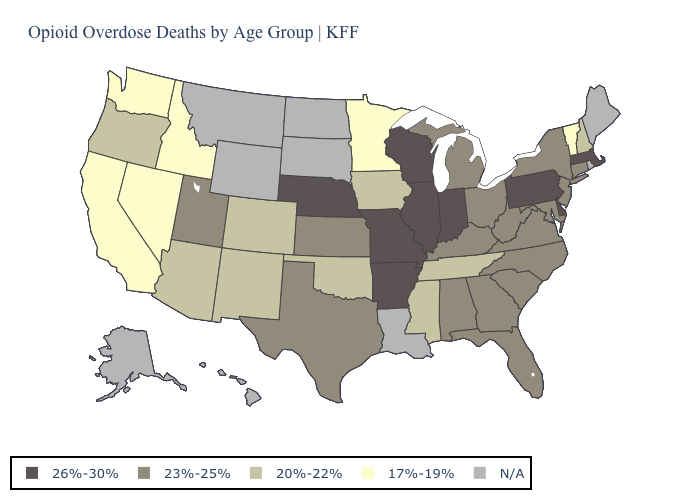What is the lowest value in the USA?
Give a very brief answer. 17%-19%. Among the states that border North Carolina , which have the highest value?
Keep it brief. Georgia, South Carolina, Virginia. What is the lowest value in the USA?
Be succinct. 17%-19%. Does the map have missing data?
Be succinct. Yes. Among the states that border Utah , does Idaho have the highest value?
Quick response, please. No. What is the value of Wyoming?
Quick response, please. N/A. What is the value of Oregon?
Write a very short answer. 20%-22%. What is the lowest value in the South?
Be succinct. 20%-22%. What is the value of West Virginia?
Short answer required. 23%-25%. What is the highest value in the USA?
Write a very short answer. 26%-30%. Name the states that have a value in the range N/A?
Give a very brief answer. Alaska, Hawaii, Louisiana, Maine, Montana, North Dakota, Rhode Island, South Dakota, Wyoming. What is the lowest value in states that border Idaho?
Quick response, please. 17%-19%. Among the states that border Wisconsin , does Illinois have the highest value?
Answer briefly. Yes. What is the value of Maryland?
Give a very brief answer. 23%-25%. 